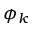<formula> <loc_0><loc_0><loc_500><loc_500>\phi _ { k }</formula> 